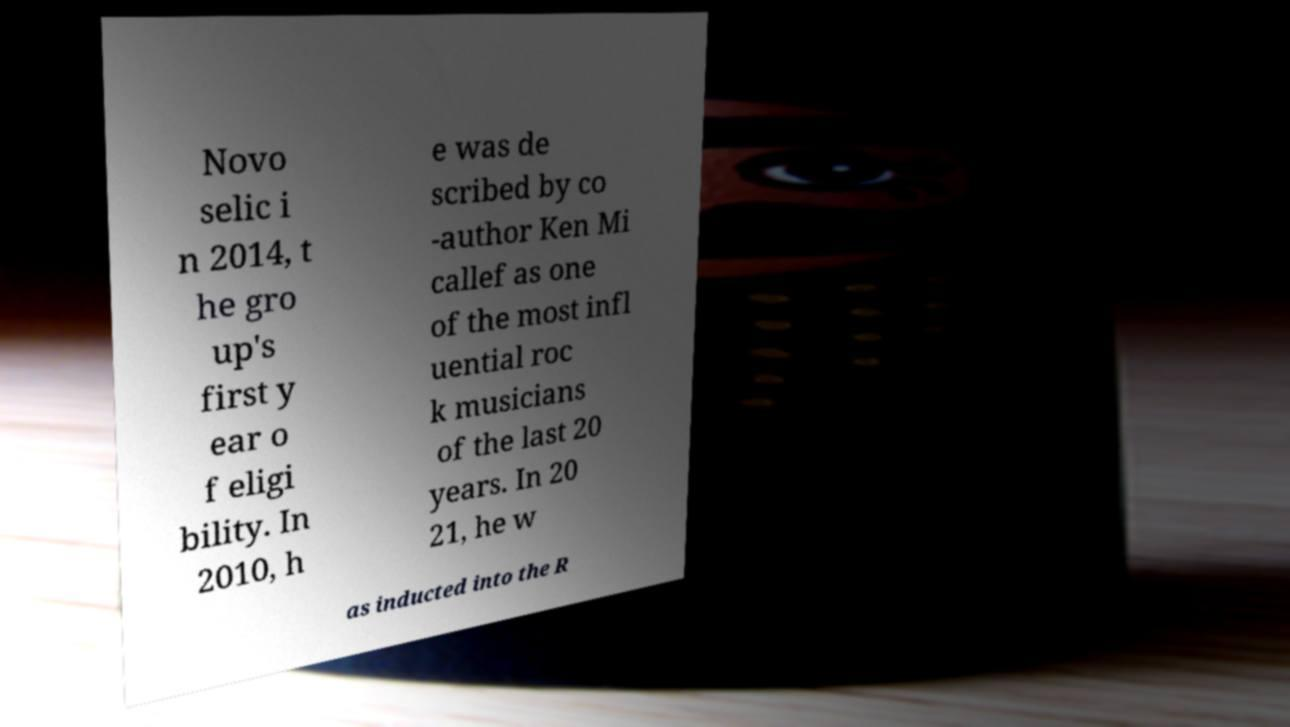I need the written content from this picture converted into text. Can you do that? Novo selic i n 2014, t he gro up's first y ear o f eligi bility. In 2010, h e was de scribed by co -author Ken Mi callef as one of the most infl uential roc k musicians of the last 20 years. In 20 21, he w as inducted into the R 